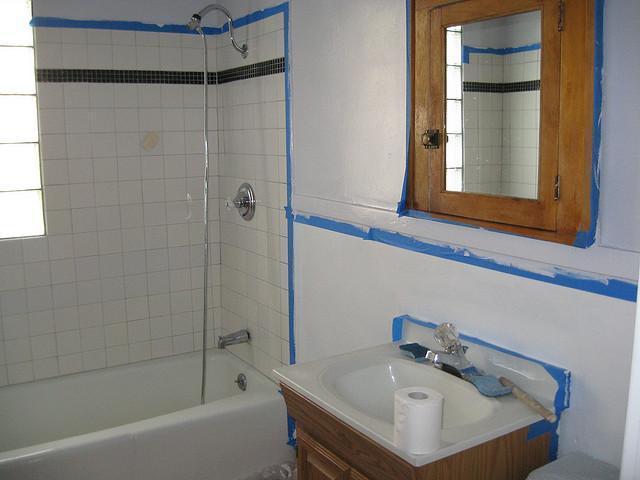How many towel racks are there?
Give a very brief answer. 0. 